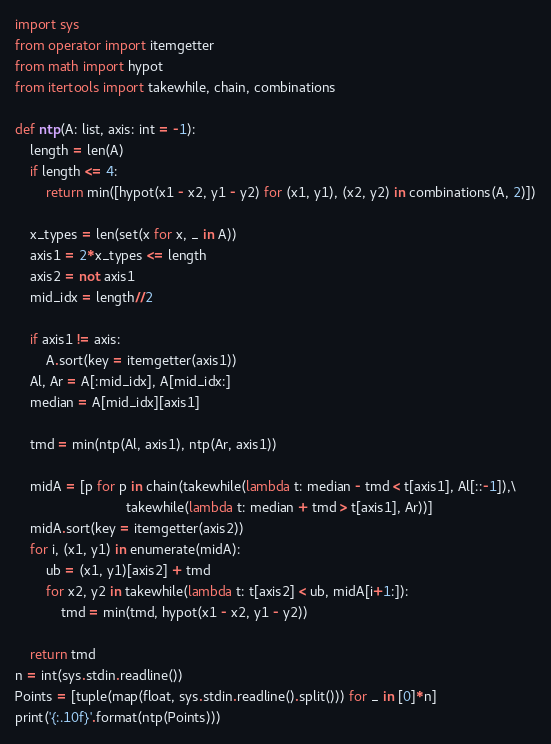Convert code to text. <code><loc_0><loc_0><loc_500><loc_500><_Python_>import sys
from operator import itemgetter
from math import hypot
from itertools import takewhile, chain, combinations

def ntp(A: list, axis: int = -1):
    length = len(A)
    if length <= 4:
        return min([hypot(x1 - x2, y1 - y2) for (x1, y1), (x2, y2) in combinations(A, 2)])
    
    x_types = len(set(x for x, _ in A))
    axis1 = 2*x_types <= length
    axis2 = not axis1
    mid_idx = length//2
    
    if axis1 != axis:
        A.sort(key = itemgetter(axis1))
    Al, Ar = A[:mid_idx], A[mid_idx:]
    median = A[mid_idx][axis1]
    
    tmd = min(ntp(Al, axis1), ntp(Ar, axis1))
    
    midA = [p for p in chain(takewhile(lambda t: median - tmd < t[axis1], Al[::-1]),\
                             takewhile(lambda t: median + tmd > t[axis1], Ar))]
    midA.sort(key = itemgetter(axis2))
    for i, (x1, y1) in enumerate(midA):
        ub = (x1, y1)[axis2] + tmd
        for x2, y2 in takewhile(lambda t: t[axis2] < ub, midA[i+1:]):
            tmd = min(tmd, hypot(x1 - x2, y1 - y2))
    
    return tmd
n = int(sys.stdin.readline())
Points = [tuple(map(float, sys.stdin.readline().split())) for _ in [0]*n] 
print('{:.10f}'.format(ntp(Points)))

</code> 